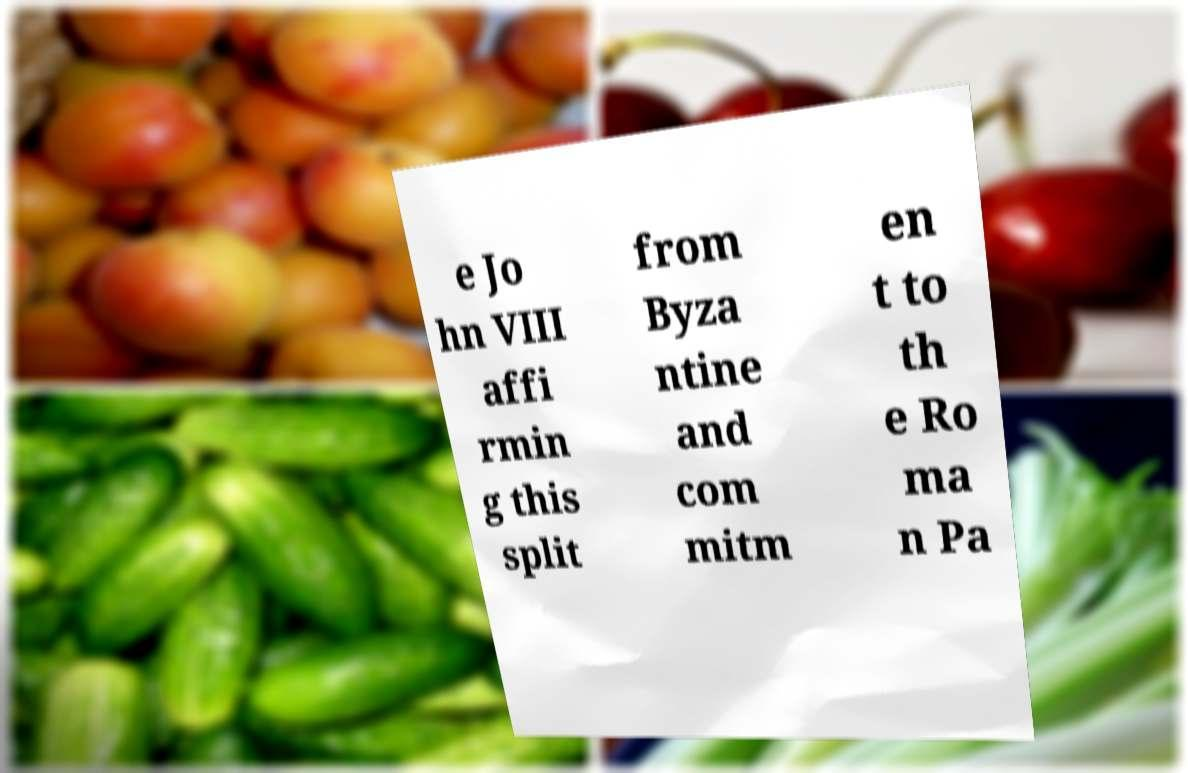For documentation purposes, I need the text within this image transcribed. Could you provide that? e Jo hn VIII affi rmin g this split from Byza ntine and com mitm en t to th e Ro ma n Pa 